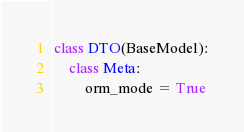Convert code to text. <code><loc_0><loc_0><loc_500><loc_500><_Python_>class DTO(BaseModel):
    class Meta:
        orm_mode = True
</code> 